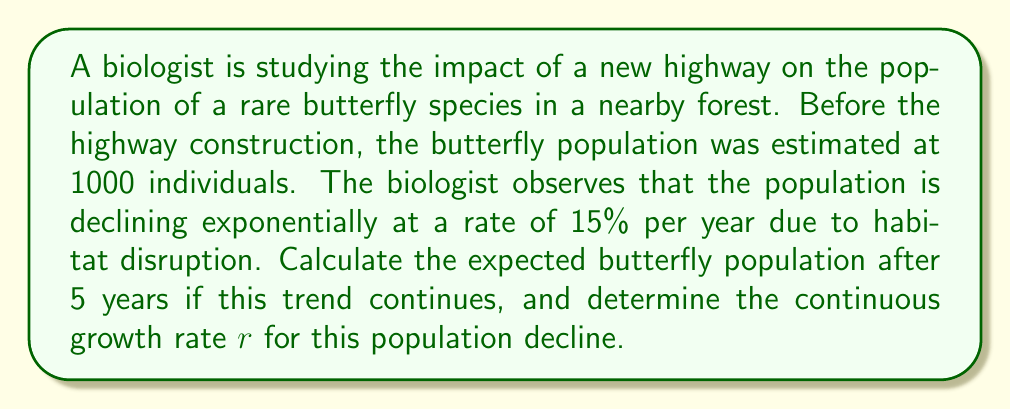Solve this math problem. To solve this problem, we'll use the exponential growth model:

$$N(t) = N_0 e^{rt}$$

Where:
$N(t)$ is the population at time $t$
$N_0$ is the initial population
$r$ is the continuous growth rate
$t$ is the time period

1. First, let's calculate the population after 5 years:
   We're given a discrete annual rate of -15% (decline), which we need to convert to a continuous rate.

   The relationship between discrete rate $R$ and continuous rate $r$ is:
   $$e^r = 1 + R$$

   $$r = \ln(1 + R)$$
   $$r = \ln(1 - 0.15) = -0.1625$$

   Now we can use the exponential model:
   $$N(5) = 1000 \cdot e^{-0.1625 \cdot 5}$$
   $$N(5) = 1000 \cdot e^{-0.8125}$$
   $$N(5) = 1000 \cdot 0.4437$$
   $$N(5) \approx 443.7$$

2. The continuous growth rate $r$ is already calculated: $r = -0.1625$

   Note: The negative value indicates population decline.
Answer: The expected butterfly population after 5 years is approximately 444 individuals (rounded to the nearest whole butterfly). The continuous growth rate $r$ is $-0.1625$ per year. 